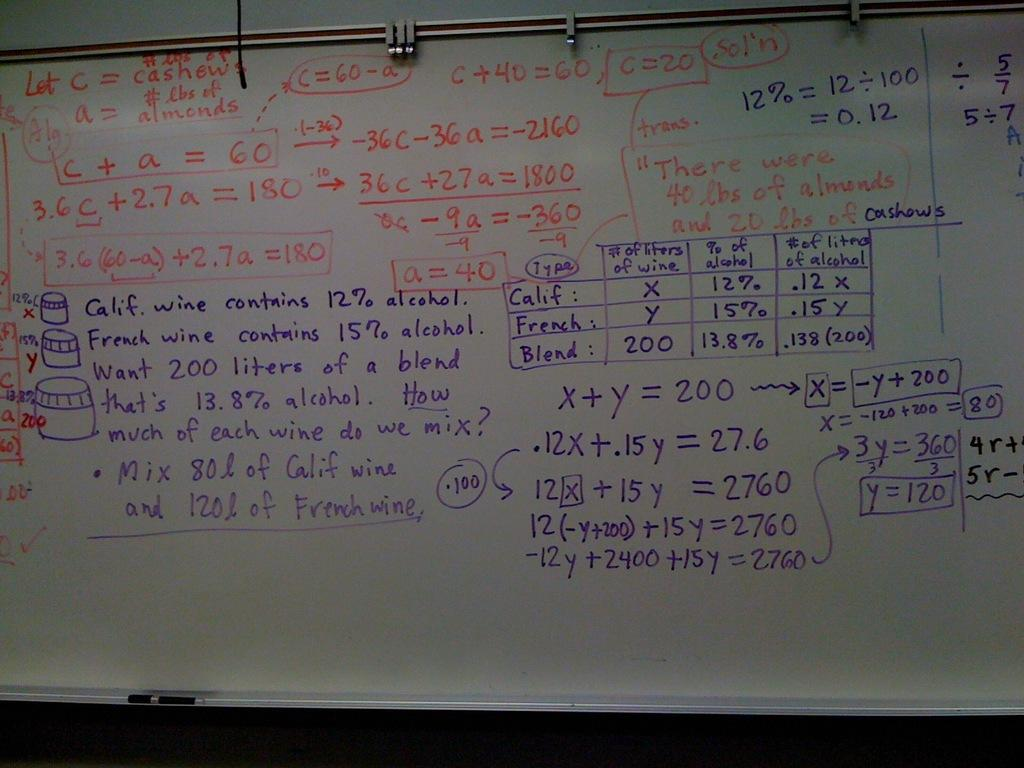<image>
Create a compact narrative representing the image presented. A whiteboard has many maths problems on it including c+a=60. 